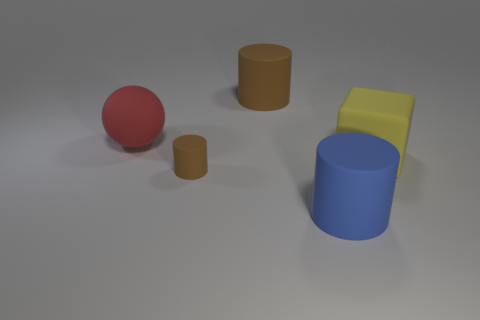Subtract all big brown rubber cylinders. How many cylinders are left? 2 Subtract all blue cylinders. How many cylinders are left? 2 Subtract all balls. How many objects are left? 4 Subtract 1 cylinders. How many cylinders are left? 2 Add 2 large green objects. How many large green objects exist? 2 Add 2 large rubber cubes. How many objects exist? 7 Subtract 0 brown spheres. How many objects are left? 5 Subtract all red cylinders. Subtract all purple blocks. How many cylinders are left? 3 Subtract all yellow cubes. How many yellow balls are left? 0 Subtract all brown cylinders. Subtract all large purple metallic cylinders. How many objects are left? 3 